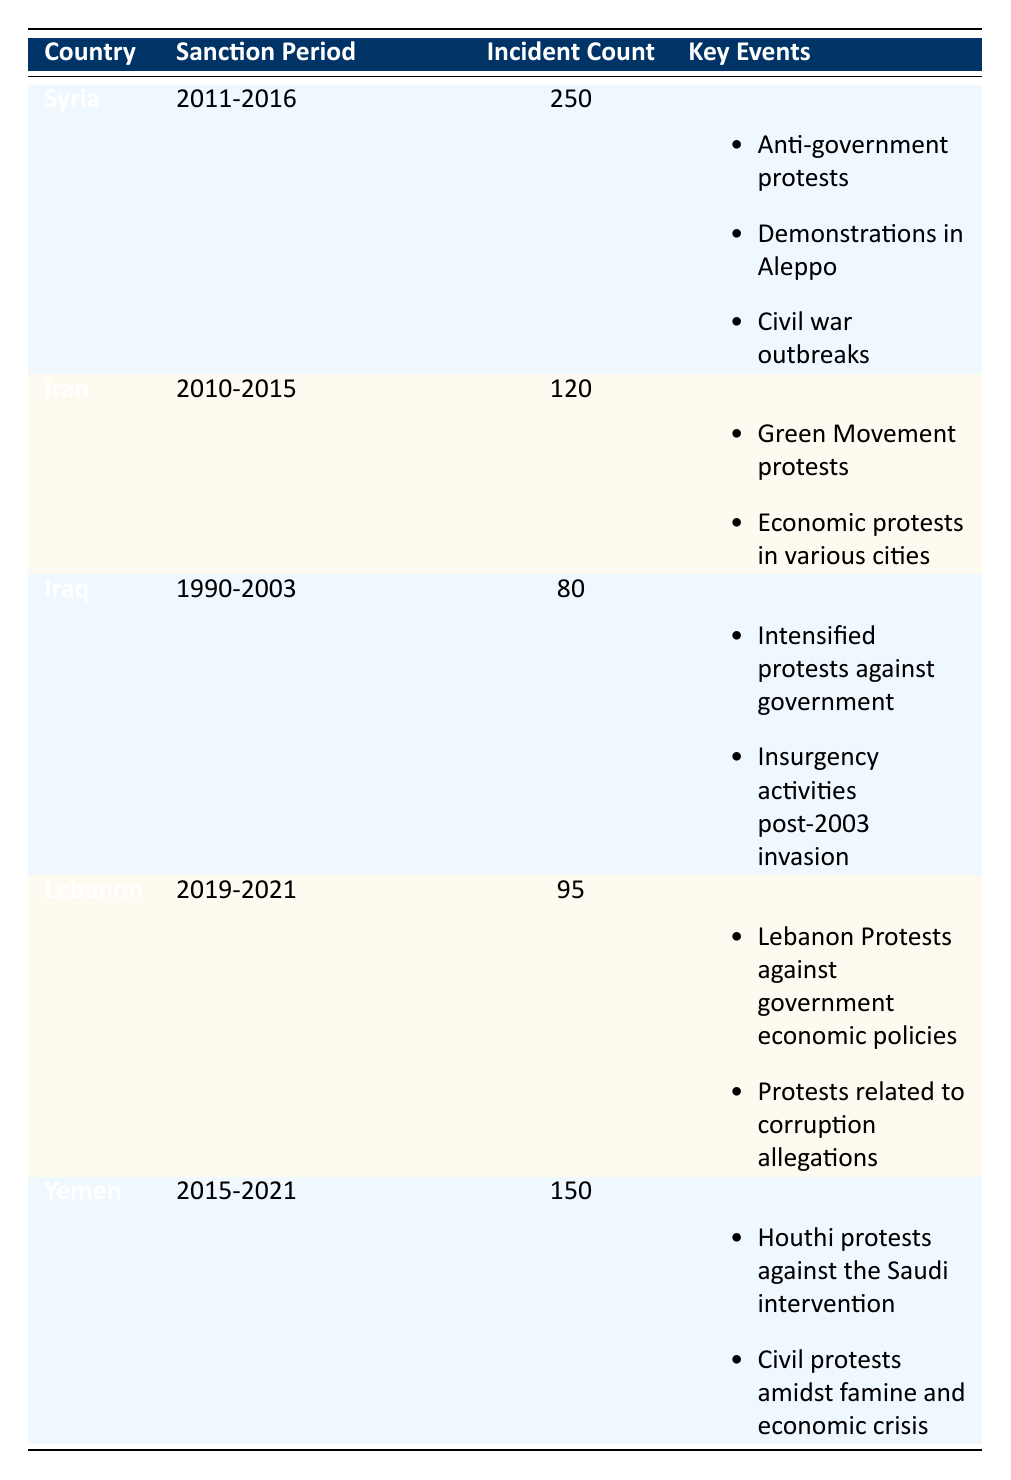What country had the most civil unrest incidents during sanction periods? By inspecting the 'Incident Count' column, we notice that Syria has the highest count with 250 incidents compared to other countries.
Answer: Syria During which period did Iran face economic sanctions? The table indicates that the sanctions period for Iran is from 2010 to 2015.
Answer: 2010-2015 Which countries had more than 100 civil unrest incidents? We can see from the 'Incident Count' that Syria (250) and Yemen (150) both have more than 100 incidents.
Answer: Syria and Yemen What is the total number of civil unrest incidents reported in Iraq and Lebanon during their sanction periods? The incident counts for Iraq is 80 and for Lebanon is 95. Adding these together gives us 80 + 95 = 175 incidents.
Answer: 175 Did Iran have more civil unrest incidents than Iraq during the sanction periods? Comparing the 'Incident Count' for both countries, Iran has 120 incidents while Iraq has 80, thus confirming that Iran had more incidents.
Answer: Yes What was the average number of civil unrest incidents across the listed countries during their sanction periods? To find the average, we add the incident counts: 250 (Syria) + 120 (Iran) + 80 (Iraq) + 95 (Lebanon) + 150 (Yemen) = 695. Then, we divide by the number of countries, which is 5. Therefore, the average is 695 / 5 = 139.
Answer: 139 Which country had incidents related to protests against government economic policies? Looking at the 'Key Events’ for Lebanon, it shows "Protests against government economic policies," indicating Lebanon is the country of interest.
Answer: Lebanon How many key events were reported during the sanction period for Yemen? According to the 'Key Events' section for Yemen, there are two events listed: "Houthi protests against the Saudi intervention" and "Civil protests amidst famine and economic crisis."
Answer: 2 